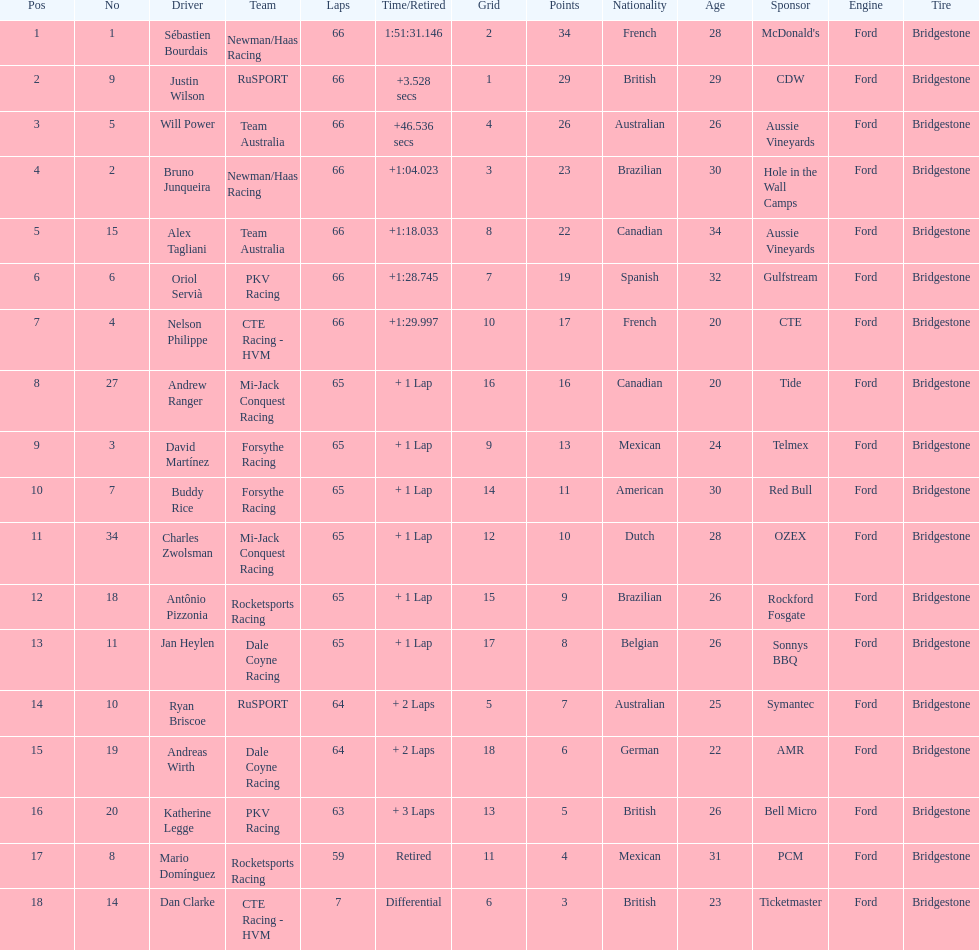At the 2006 gran premio telmex, who scored the highest number of points? Sébastien Bourdais. 